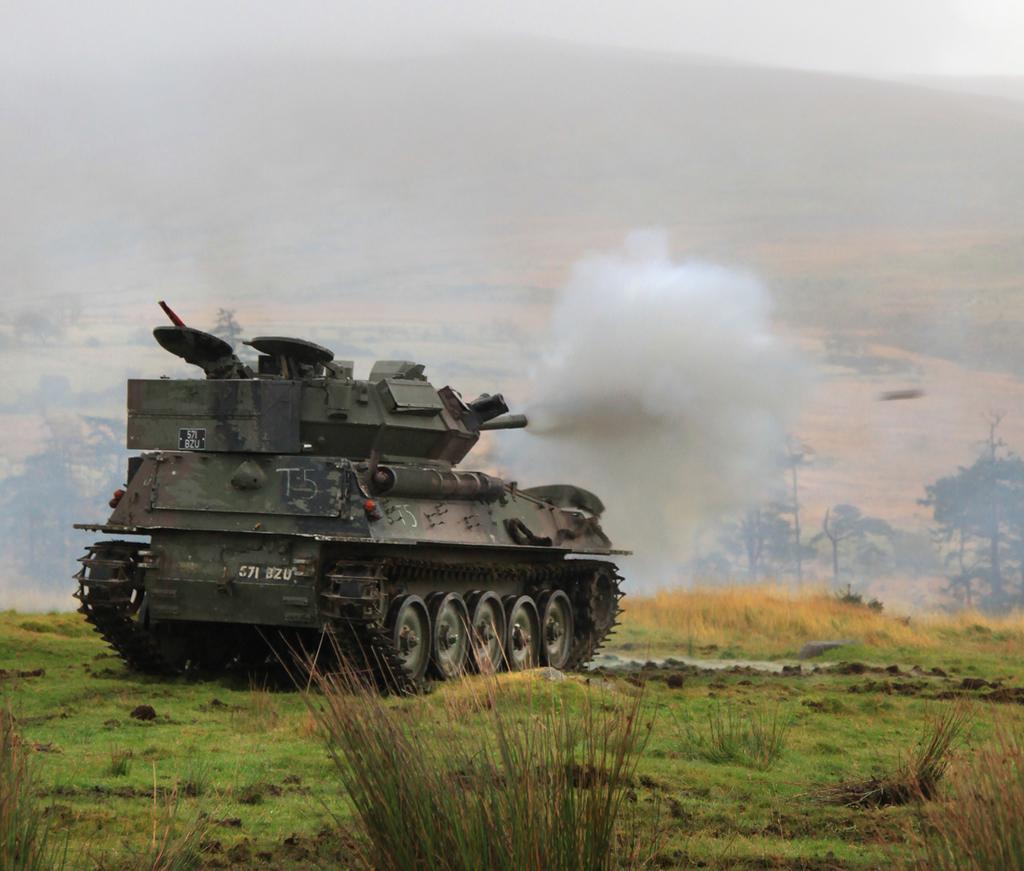Please provide a concise description of this image. This image is taken outdoors. At the bottom of the image there is a ground with grass on it. In the background there are a few trees and plants on the ground. In the middle of the image there is a tanker on the ground and it is exhibiting smoke. 